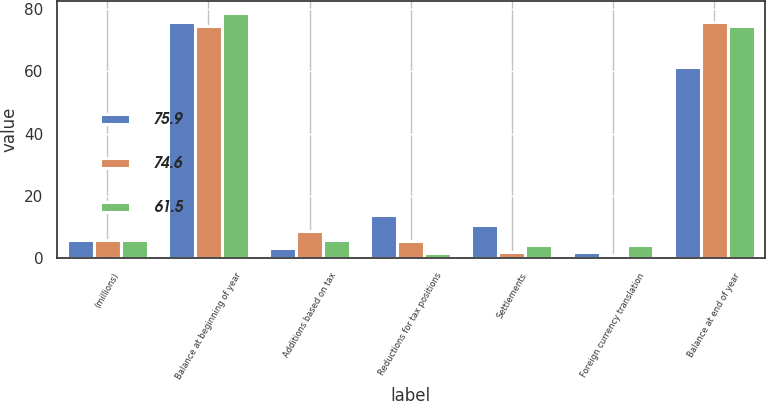<chart> <loc_0><loc_0><loc_500><loc_500><stacked_bar_chart><ecel><fcel>(millions)<fcel>Balance at beginning of year<fcel>Additions based on tax<fcel>Reductions for tax positions<fcel>Settlements<fcel>Foreign currency translation<fcel>Balance at end of year<nl><fcel>75.9<fcel>5.8<fcel>75.9<fcel>3.2<fcel>14<fcel>10.8<fcel>2.1<fcel>61.5<nl><fcel>74.6<fcel>5.8<fcel>74.6<fcel>8.8<fcel>5.5<fcel>2<fcel>1.1<fcel>75.9<nl><fcel>61.5<fcel>5.8<fcel>78.7<fcel>5.8<fcel>1.6<fcel>4.2<fcel>4.2<fcel>74.6<nl></chart> 